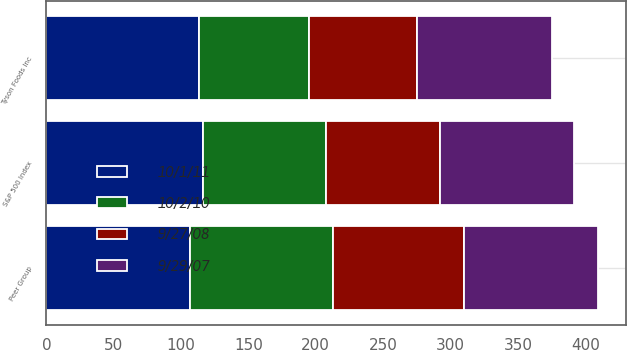Convert chart to OTSL. <chart><loc_0><loc_0><loc_500><loc_500><stacked_bar_chart><ecel><fcel>Tyson Foods Inc<fcel>S&P 500 Index<fcel>Peer Group<nl><fcel>9/29/07<fcel>100<fcel>100<fcel>100<nl><fcel>10/1/11<fcel>113.35<fcel>116.44<fcel>106.89<nl><fcel>10/2/10<fcel>81.41<fcel>90.85<fcel>106.09<nl><fcel>9/27/08<fcel>80.4<fcel>84.58<fcel>96.68<nl></chart> 